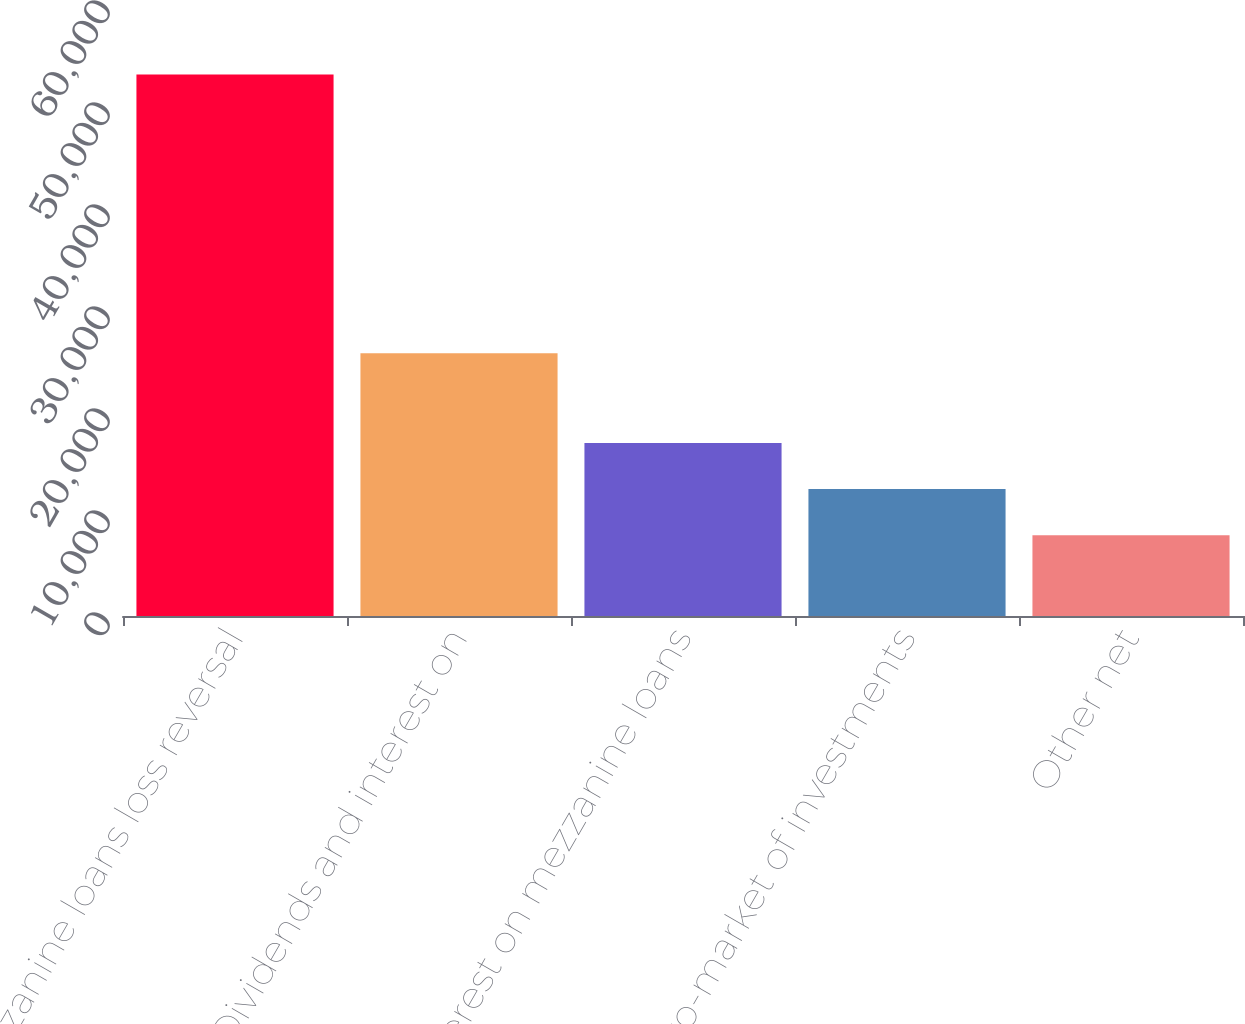<chart> <loc_0><loc_0><loc_500><loc_500><bar_chart><fcel>Mezzanine loans loss reversal<fcel>Dividends and interest on<fcel>Interest on mezzanine loans<fcel>Mark-to-market of investments<fcel>Other net<nl><fcel>53100<fcel>25772<fcel>16957.6<fcel>12439.8<fcel>7922<nl></chart> 